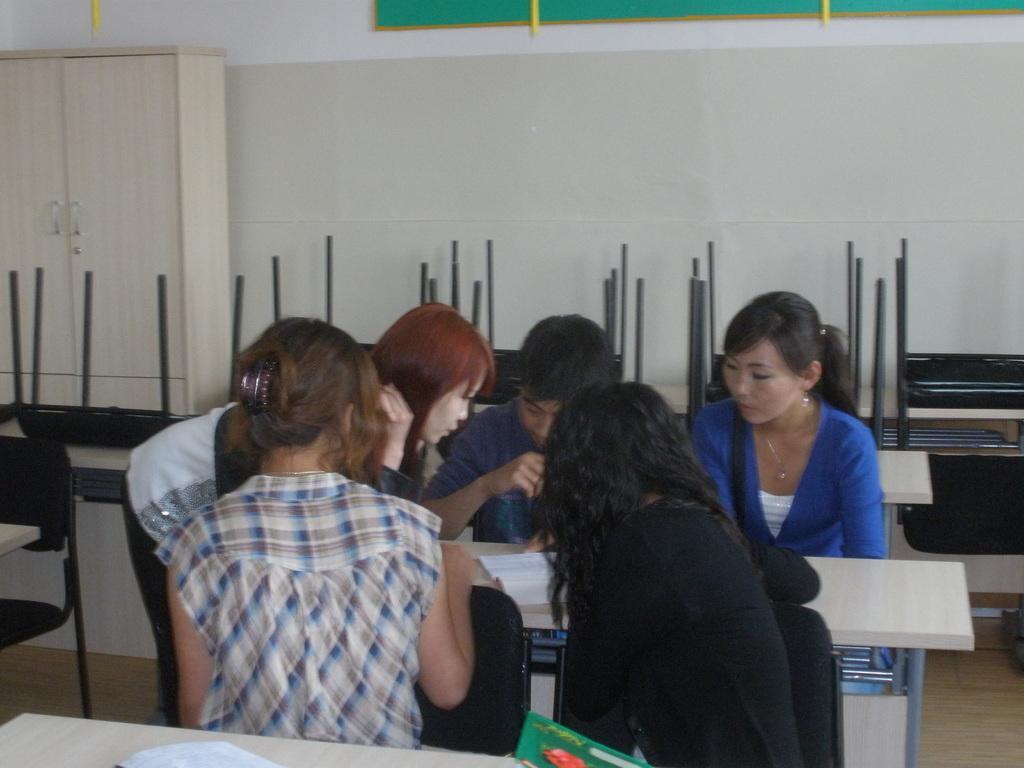Describe this image in one or two sentences. This image taken in a room, there are group of people here. There is table in the middle, there is a book on the table. In the right side of the image there is a woman wearing blue coat. In the middle there is a woman tied her hair with the clutch, there is a chair in the left side of the image, there is a cupboard in the left side of the image. There is a board on the wall. 